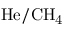<formula> <loc_0><loc_0><loc_500><loc_500>H e / C H _ { 4 }</formula> 